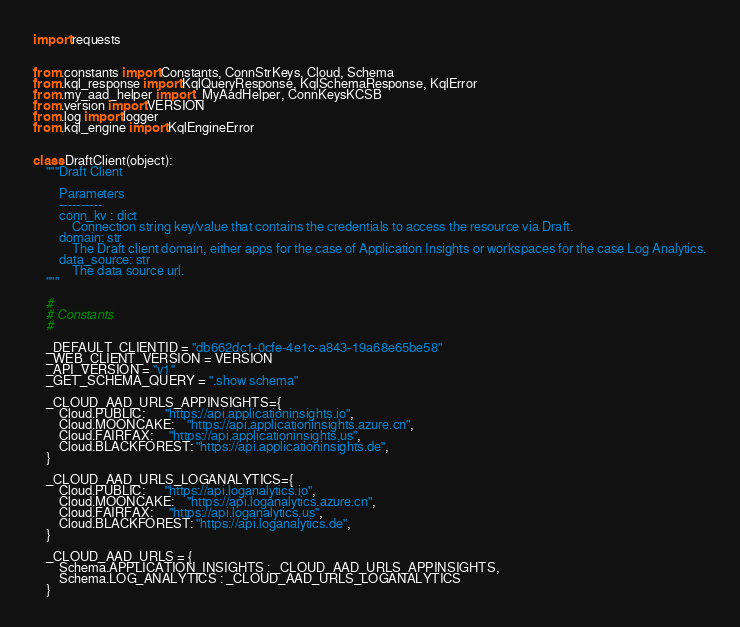Convert code to text. <code><loc_0><loc_0><loc_500><loc_500><_Python_>import requests


from .constants import Constants, ConnStrKeys, Cloud, Schema
from .kql_response import KqlQueryResponse, KqlSchemaResponse, KqlError
from .my_aad_helper import _MyAadHelper, ConnKeysKCSB
from .version import VERSION
from .log import logger
from .kql_engine import KqlEngineError


class DraftClient(object):
    """Draft Client

        Parameters
        ----------
        conn_kv : dict
            Connection string key/value that contains the credentials to access the resource via Draft.
        domain: str
            The Draft client domain, either apps for the case of Application Insights or workspaces for the case Log Analytics.
        data_source: str
            The data source url.
    """

    #
    # Constants
    #

    _DEFAULT_CLIENTID = "db662dc1-0cfe-4e1c-a843-19a68e65be58"
    _WEB_CLIENT_VERSION = VERSION
    _API_VERSION = "v1"
    _GET_SCHEMA_QUERY = ".show schema"

    _CLOUD_AAD_URLS_APPINSIGHTS={
        Cloud.PUBLIC:      "https://api.applicationinsights.io",
        Cloud.MOONCAKE:    "https://api.applicationinsights.azure.cn",
        Cloud.FAIRFAX:     "https://api.applicationinsights.us",
        Cloud.BLACKFOREST: "https://api.applicationinsights.de",
    }

    _CLOUD_AAD_URLS_LOGANALYTICS={
        Cloud.PUBLIC:      "https://api.loganalytics.io",
        Cloud.MOONCAKE:    "https://api.loganalytics.azure.cn",
        Cloud.FAIRFAX:     "https://api.loganalytics.us",
        Cloud.BLACKFOREST: "https://api.loganalytics.de",
    }

    _CLOUD_AAD_URLS = {
        Schema.APPLICATION_INSIGHTS : _CLOUD_AAD_URLS_APPINSIGHTS,
        Schema.LOG_ANALYTICS : _CLOUD_AAD_URLS_LOGANALYTICS
    }

</code> 